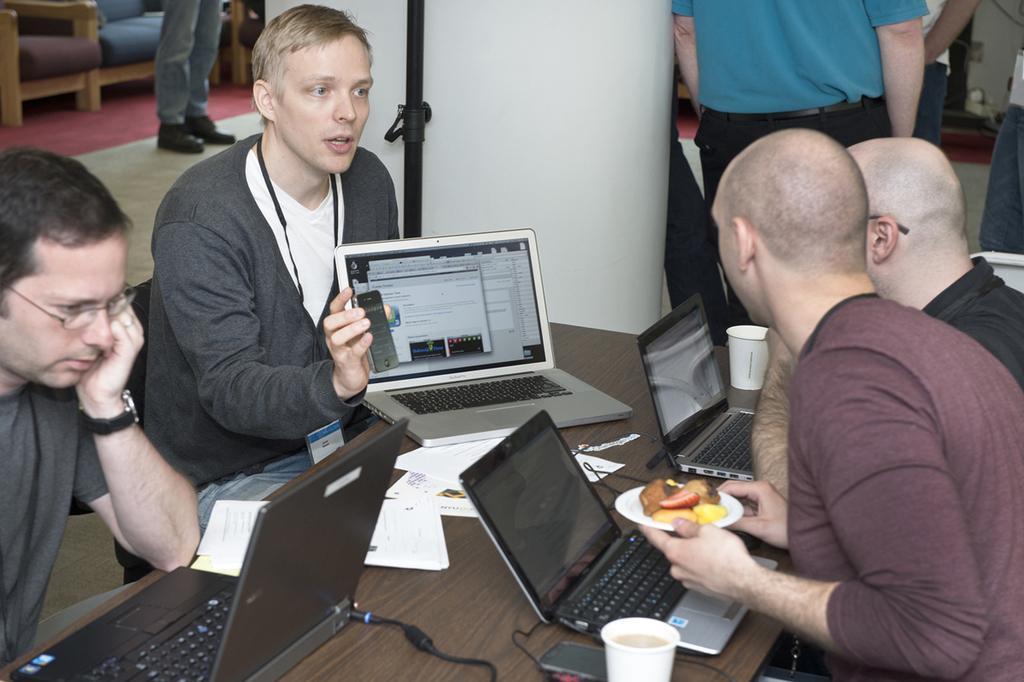Could you give a brief overview of what you see in this image? In this image we can see persons sitting at the table on the chairs and laptops are placed in front of them. The persons are holding plate with food in it, disposal tumblers and a mobile phone. In the background we can see carpet, floor, persons standing on the floor and chairs. 